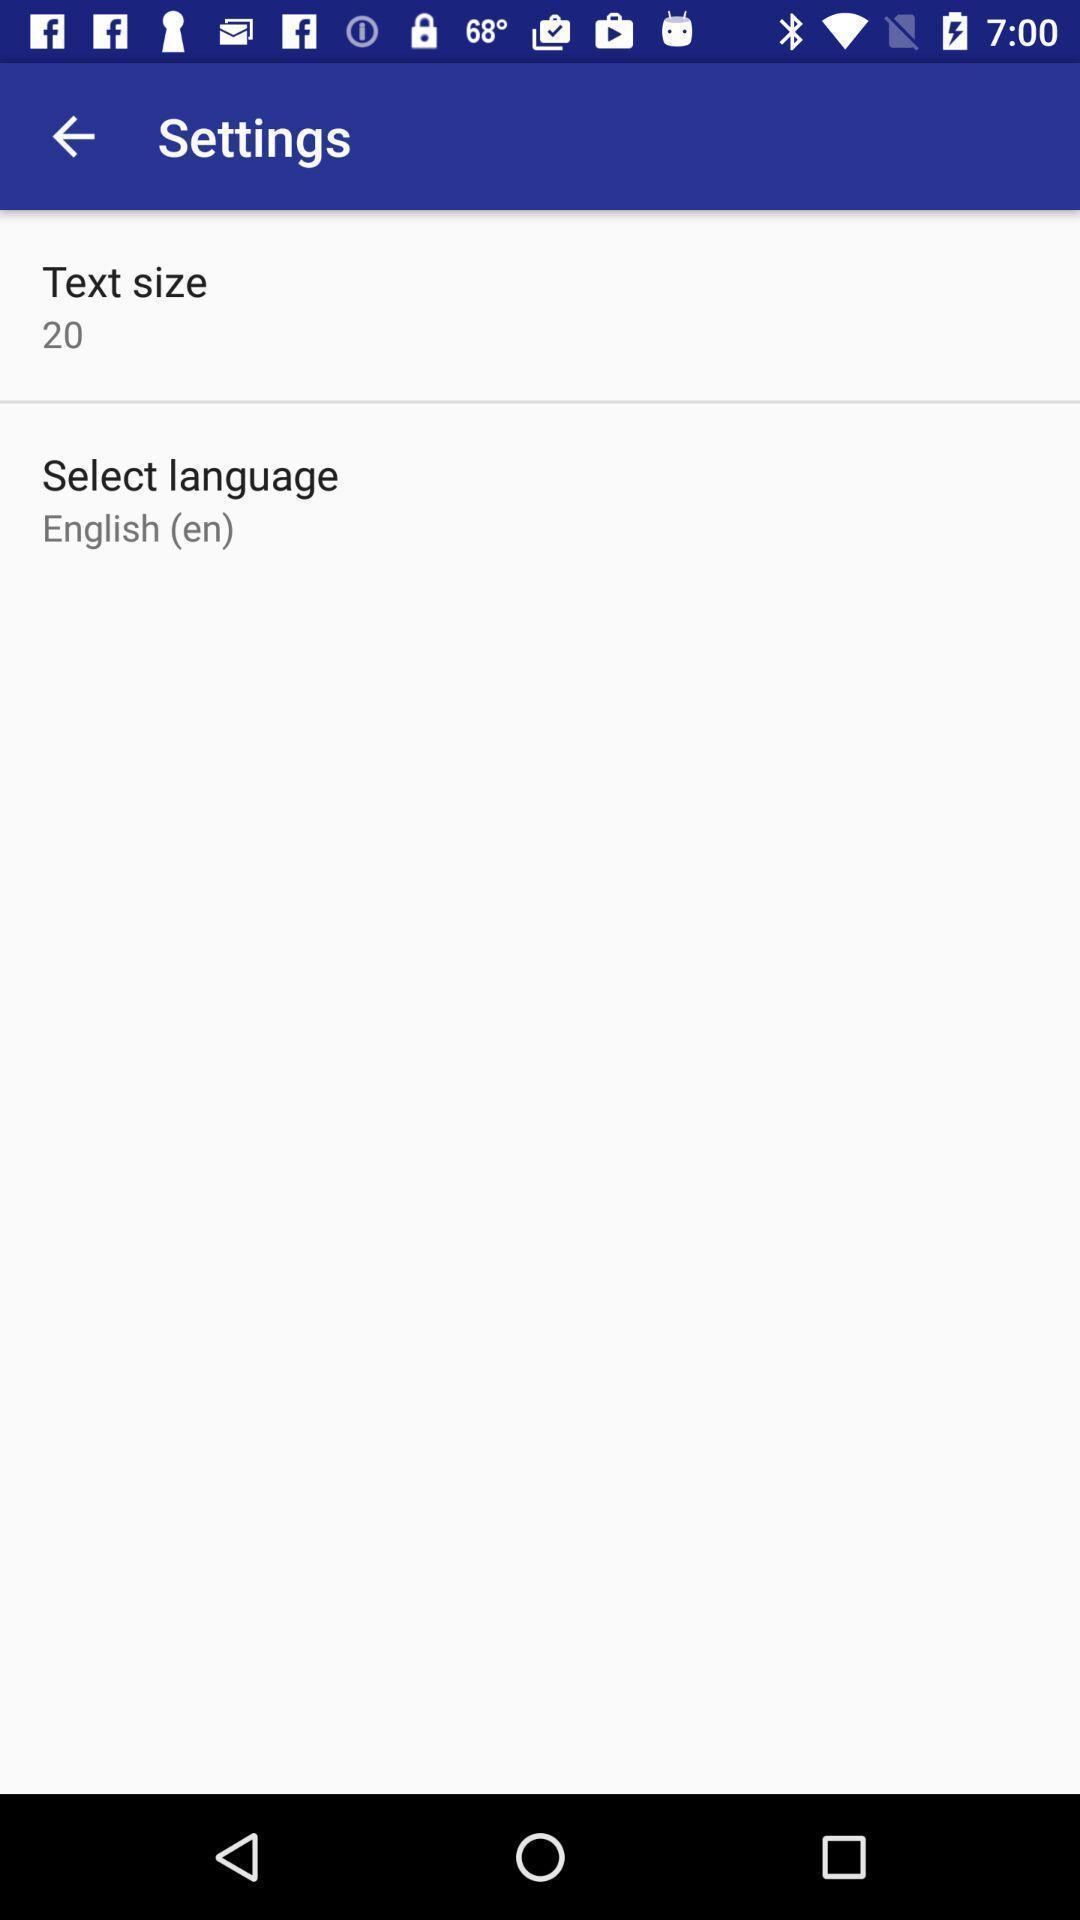Describe this image in words. Settings page displaying in application. 